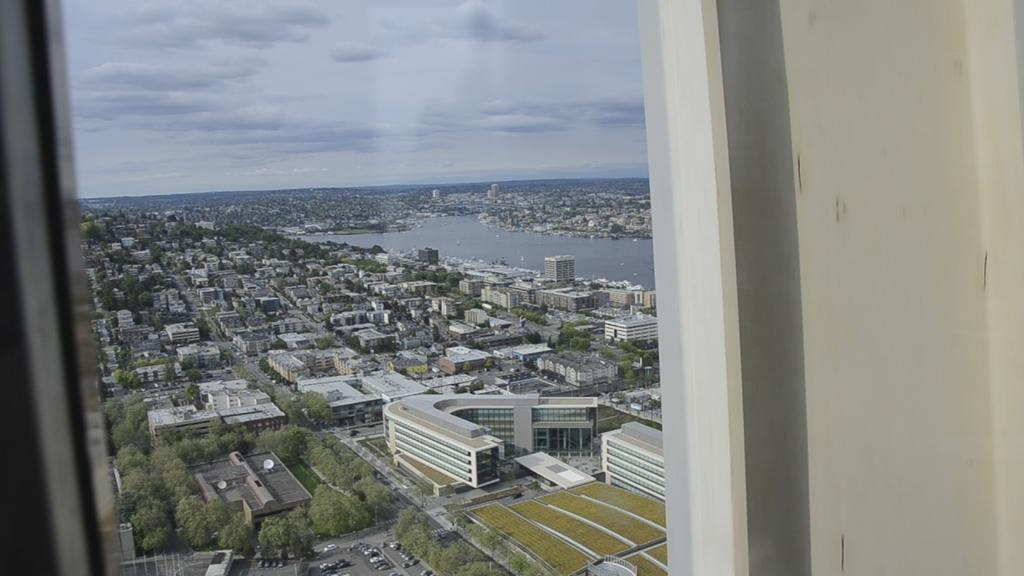What type of structures can be seen in the image? There are buildings in the image. What natural elements are present in the image? There are trees and water visible in the image. What architectural feature can be seen in the image? There is a wall in the image. What part of the natural environment is visible in the background of the image? The sky is visible in the background of the image. What type of breakfast is being served in the image? There is no breakfast present in the image; it features buildings, trees, water, a wall, and the sky. How many dogs can be seen playing in the scene? There are no dogs present in the image; it does not depict a scene with animals. 